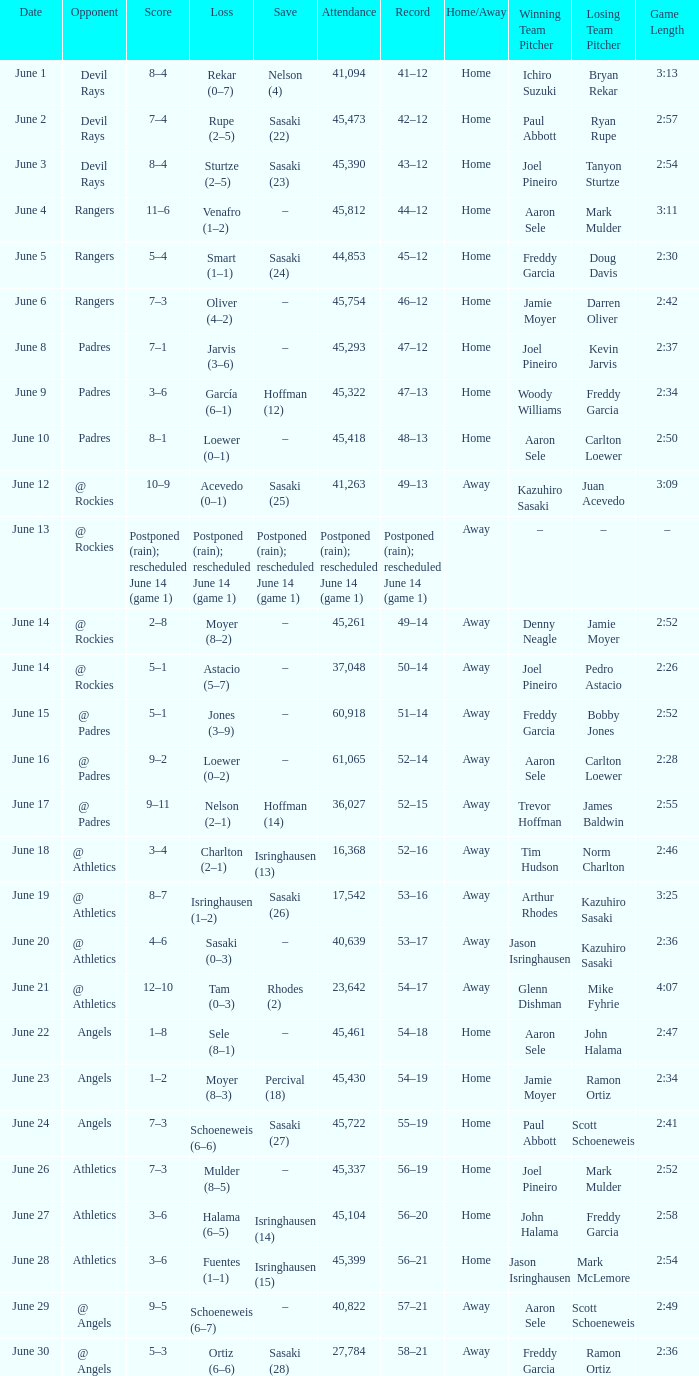What was the date of the Mariners game when they had a record of 53–17? June 20. 